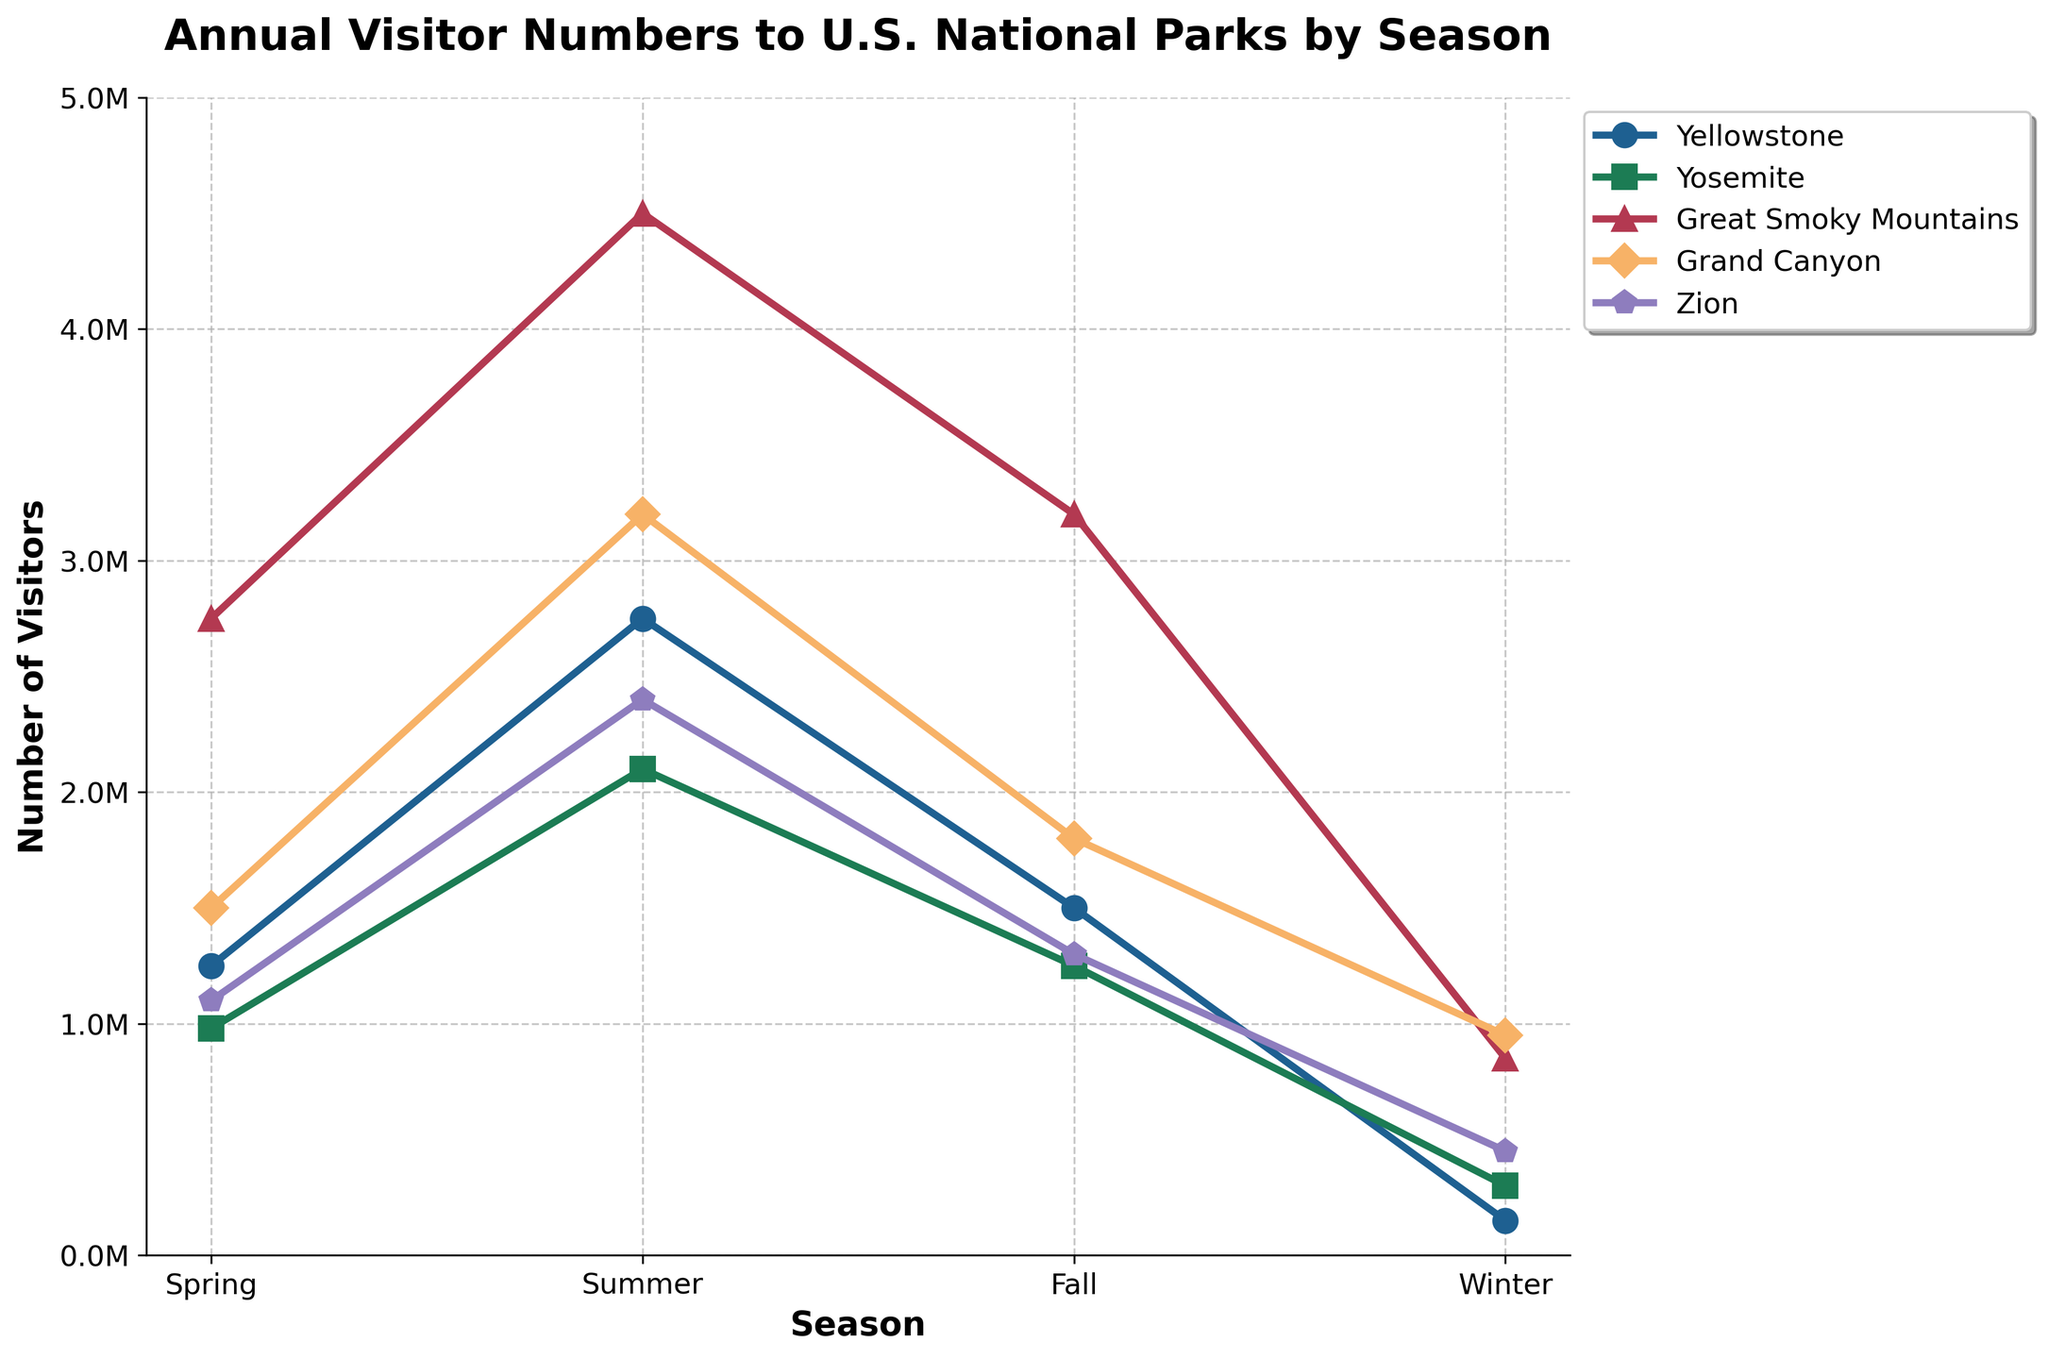Which park had the highest number of visitors in the summer? To find the highest number of visitors in the summer, look at the summer data across all parks. The Great Smoky Mountains had 4,500,000 visitors, which is the highest number.
Answer: Great Smoky Mountains Compare the number of visitors to Yosemite in spring and fall. Which season had more visitors? Find the number of visitors in spring and fall for Yosemite. Spring had 980,000 visitors and fall had 1,250,000 visitors, so fall had more visitors.
Answer: Fall Which season had the lowest number of visitors at Yellowstone? Examine the visitor numbers for each season at Yellowstone. Winter had the lowest number with 150,000 visitors.
Answer: Winter Calculate the total number of visitors to Grand Canyon in all seasons. Add the number of visitors in all seasons for the Grand Canyon: 1,500,000 (Spring) + 3,200,000 (Summer) + 1,800,000 (Fall) + 950,000 (Winter) = 7,450,000.
Answer: 7,450,000 Which season had the smallest difference in visitor numbers between Yellowstone and Yosemite? Calculate the differences for each season: 
Spring: 1,250,000 - 980,000 = 270,000 
Summer: 2,750,000 - 2,100,000 = 650,000 
Fall: 1,500,000 - 1,250,000 = 250,000 
Winter: 150,000 - 300,000 = 150,000
Winter had the smallest difference with 150,000.
Answer: Winter Which park had the most consistent visitor numbers across all seasons? Calculate the range (difference between highest and lowest values) for each park:
Yellowstone: 2,750,000 - 150,000 = 2,600,000 
Yosemite: 2,100,000 - 300,000 = 1,800,000 
Great Smoky Mountains: 4,500,000 - 850,000 = 3,650,000 
Grand Canyon: 3,200,000 - 950,000 = 2,250,000 
Zion: 2,400,000 - 450,000 = 1,950,000
Yosemite has the smallest range of 1,800,000, indicating the most consistent visitor numbers.
Answer: Yosemite Which park experienced the highest number of visitors in any single season? Check the highest visitor number across any single season for each park. The Great Smoky Mountains had the highest number with 4,500,000 visitors in summer.
Answer: Great Smoky Mountains By how much did the number of visitors to Yellowstone increase from winter to summer? Subtract the number of winter visitors from the number of summer visitors for Yellowstone: 2,750,000 - 150,000 = 2,600,000.
Answer: 2,600,000 